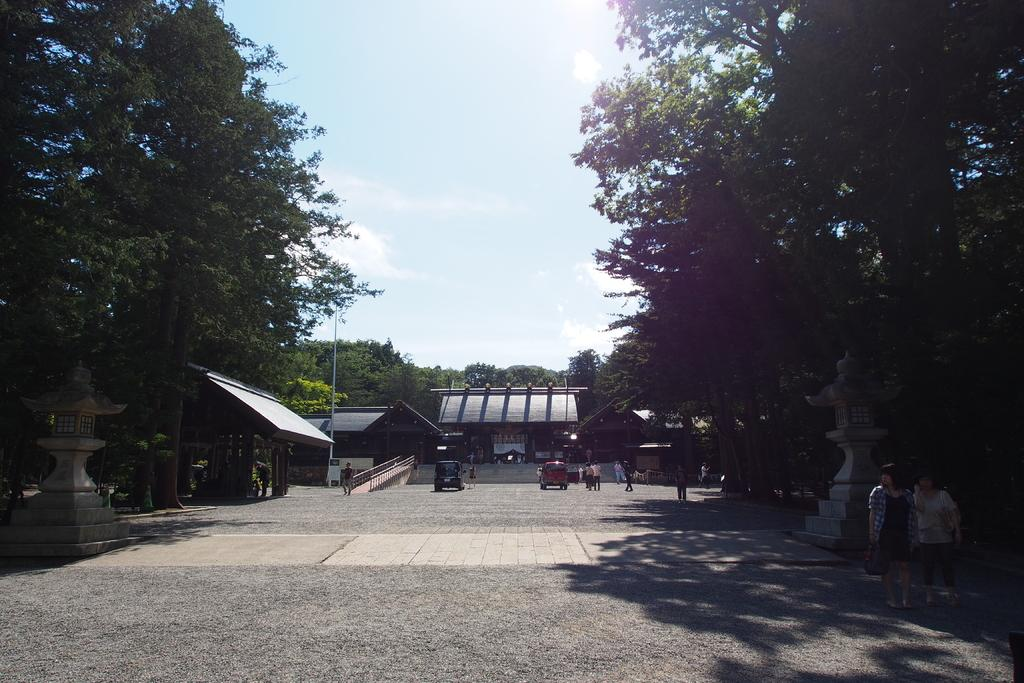Who or what can be seen in the image? There are people in the image. What else is visible on the road in the image? There are vehicles on the road in the image. What type of natural elements can be seen beside the road? Trees are present beside the road in the image. What type of structures are visible in the image? There are houses in the image. What else can be seen in the image besides people, vehicles, trees, and houses? Poles are visible in the image. What color is the sweater worn by the person in the image? There is no information about a sweater or the color of any clothing in the image. What type of answer can be seen written on the road in the image? There is no answer or writing visible on the road in the image. 